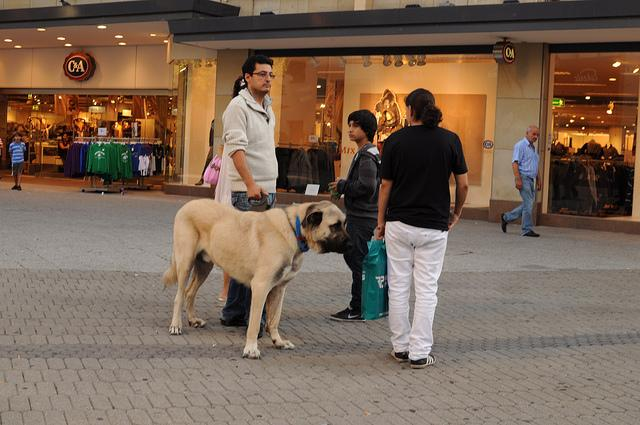What activity are the people shown involved in? shopping 